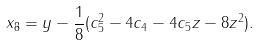<formula> <loc_0><loc_0><loc_500><loc_500>x _ { 8 } = y - \frac { 1 } { 8 } ( c _ { 5 } ^ { 2 } - 4 c _ { 4 } - 4 c _ { 5 } z - 8 z ^ { 2 } ) .</formula> 